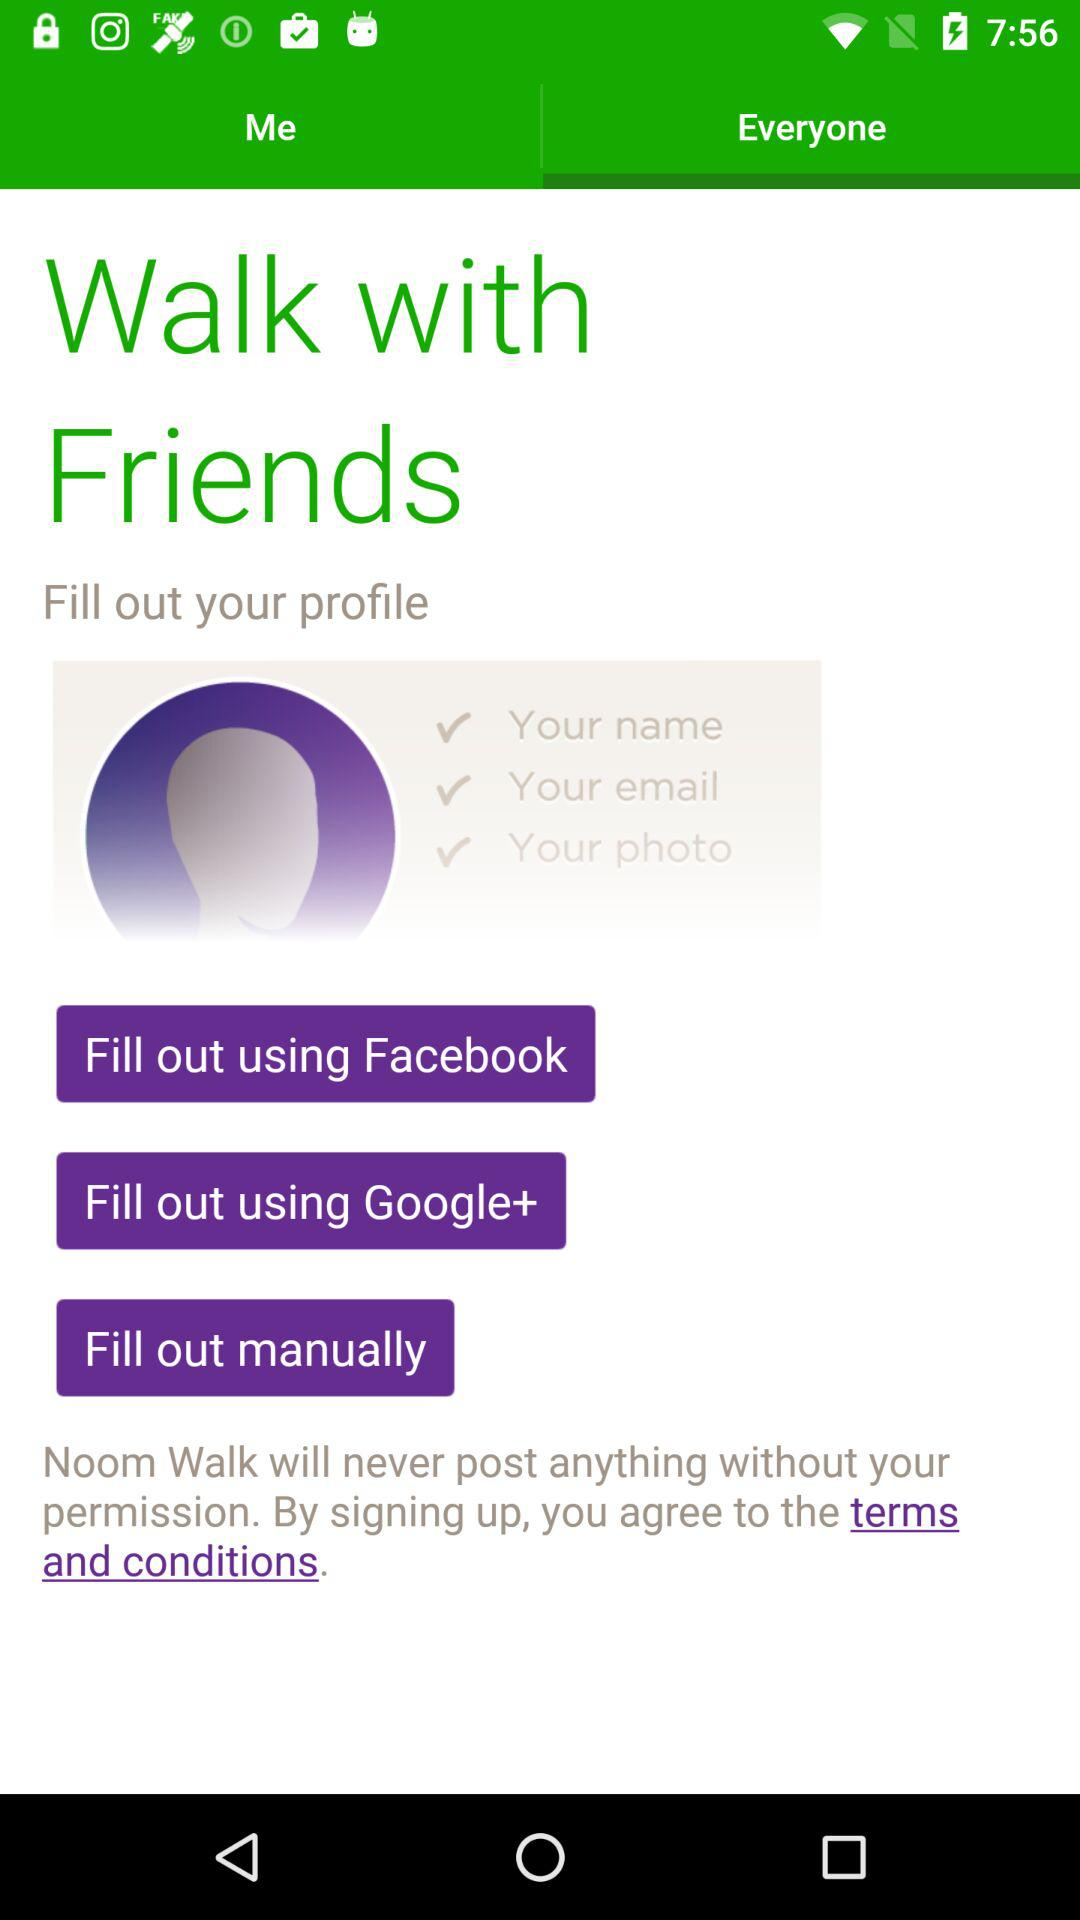Has the user agreed to the terms and conditions?
When the provided information is insufficient, respond with <no answer>. <no answer> 